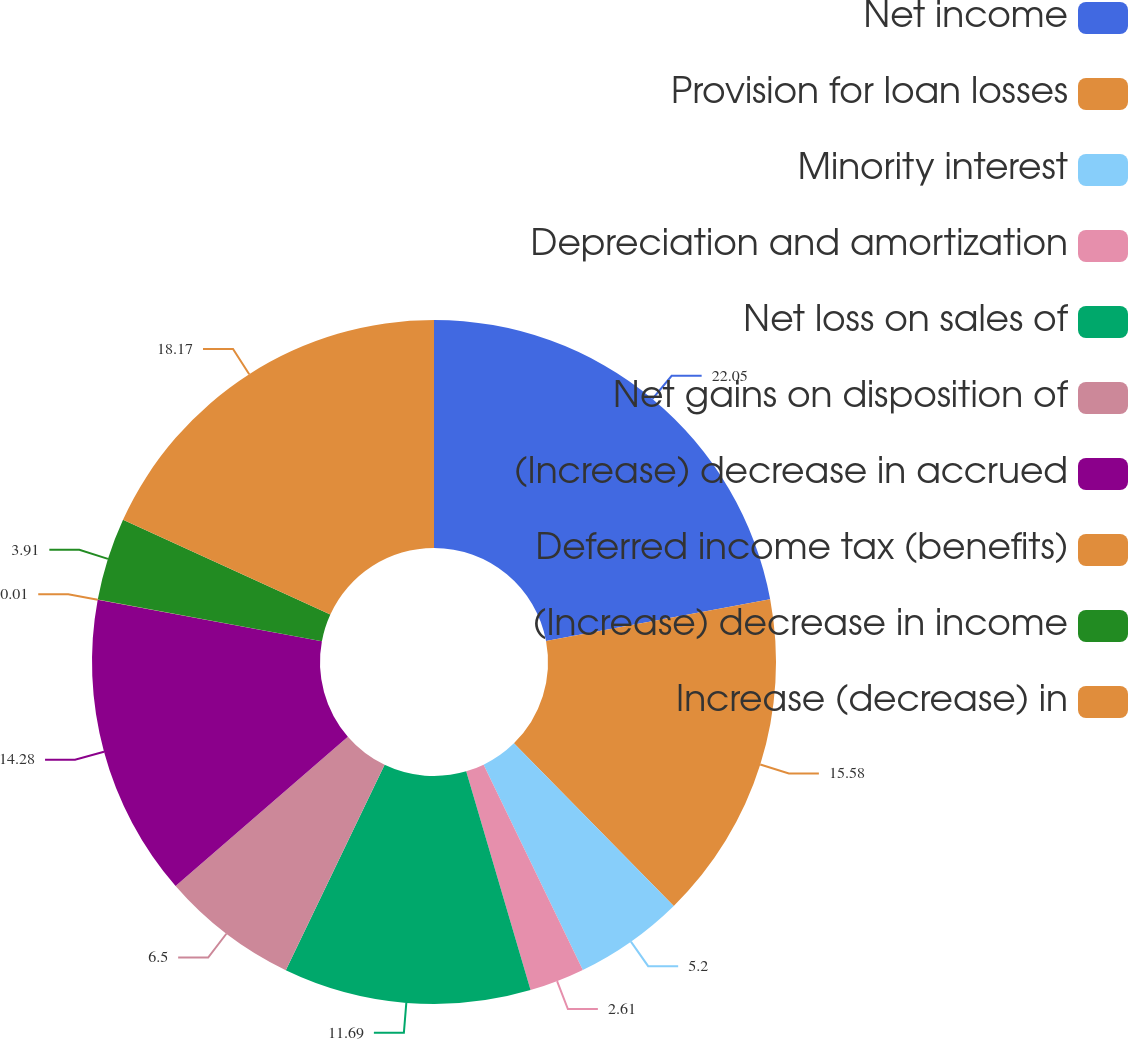<chart> <loc_0><loc_0><loc_500><loc_500><pie_chart><fcel>Net income<fcel>Provision for loan losses<fcel>Minority interest<fcel>Depreciation and amortization<fcel>Net loss on sales of<fcel>Net gains on disposition of<fcel>(Increase) decrease in accrued<fcel>Deferred income tax (benefits)<fcel>(Increase) decrease in income<fcel>Increase (decrease) in<nl><fcel>22.06%<fcel>15.58%<fcel>5.2%<fcel>2.61%<fcel>11.69%<fcel>6.5%<fcel>14.28%<fcel>0.01%<fcel>3.91%<fcel>18.17%<nl></chart> 